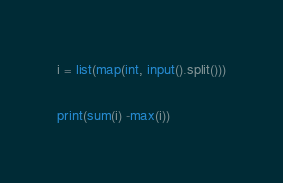Convert code to text. <code><loc_0><loc_0><loc_500><loc_500><_Python_>i = list(map(int, input().split()))

print(sum(i) -max(i))</code> 